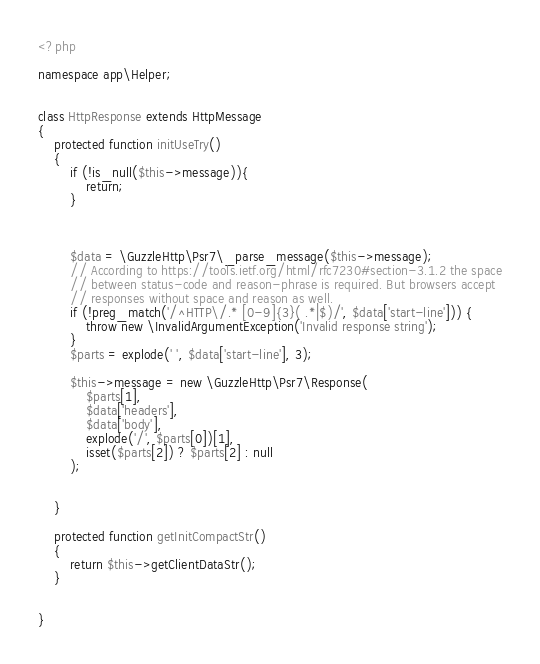<code> <loc_0><loc_0><loc_500><loc_500><_PHP_><?php

namespace app\Helper;


class HttpResponse extends HttpMessage
{
    protected function initUseTry()
    {
        if (!is_null($this->message)){
            return;
        }
    
    
    
        $data = \GuzzleHttp\Psr7\_parse_message($this->message);
        // According to https://tools.ietf.org/html/rfc7230#section-3.1.2 the space
        // between status-code and reason-phrase is required. But browsers accept
        // responses without space and reason as well.
        if (!preg_match('/^HTTP\/.* [0-9]{3}( .*|$)/', $data['start-line'])) {
            throw new \InvalidArgumentException('Invalid response string');
        }
        $parts = explode(' ', $data['start-line'], 3);
    
        $this->message = new \GuzzleHttp\Psr7\Response(
            $parts[1],
            $data['headers'],
            $data['body'],
            explode('/', $parts[0])[1],
            isset($parts[2]) ? $parts[2] : null
        );
        
        
    }
    
    protected function getInitCompactStr()
    {
        return $this->getClientDataStr();
    }
    
    
}</code> 